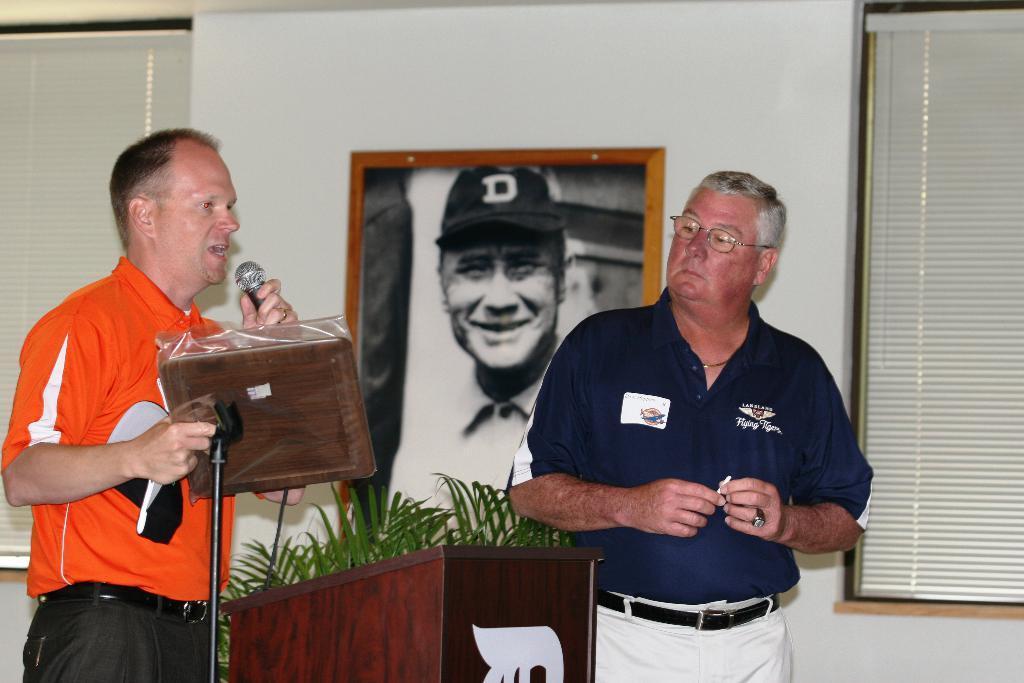Describe this image in one or two sentences. In this image there is a person holding an object and a mike. There is a window and a wall on the left corner. There is a window on the right corner. There is a person, podium and a potted plant in the foreground. There is a photo frame on the wall in the background. 